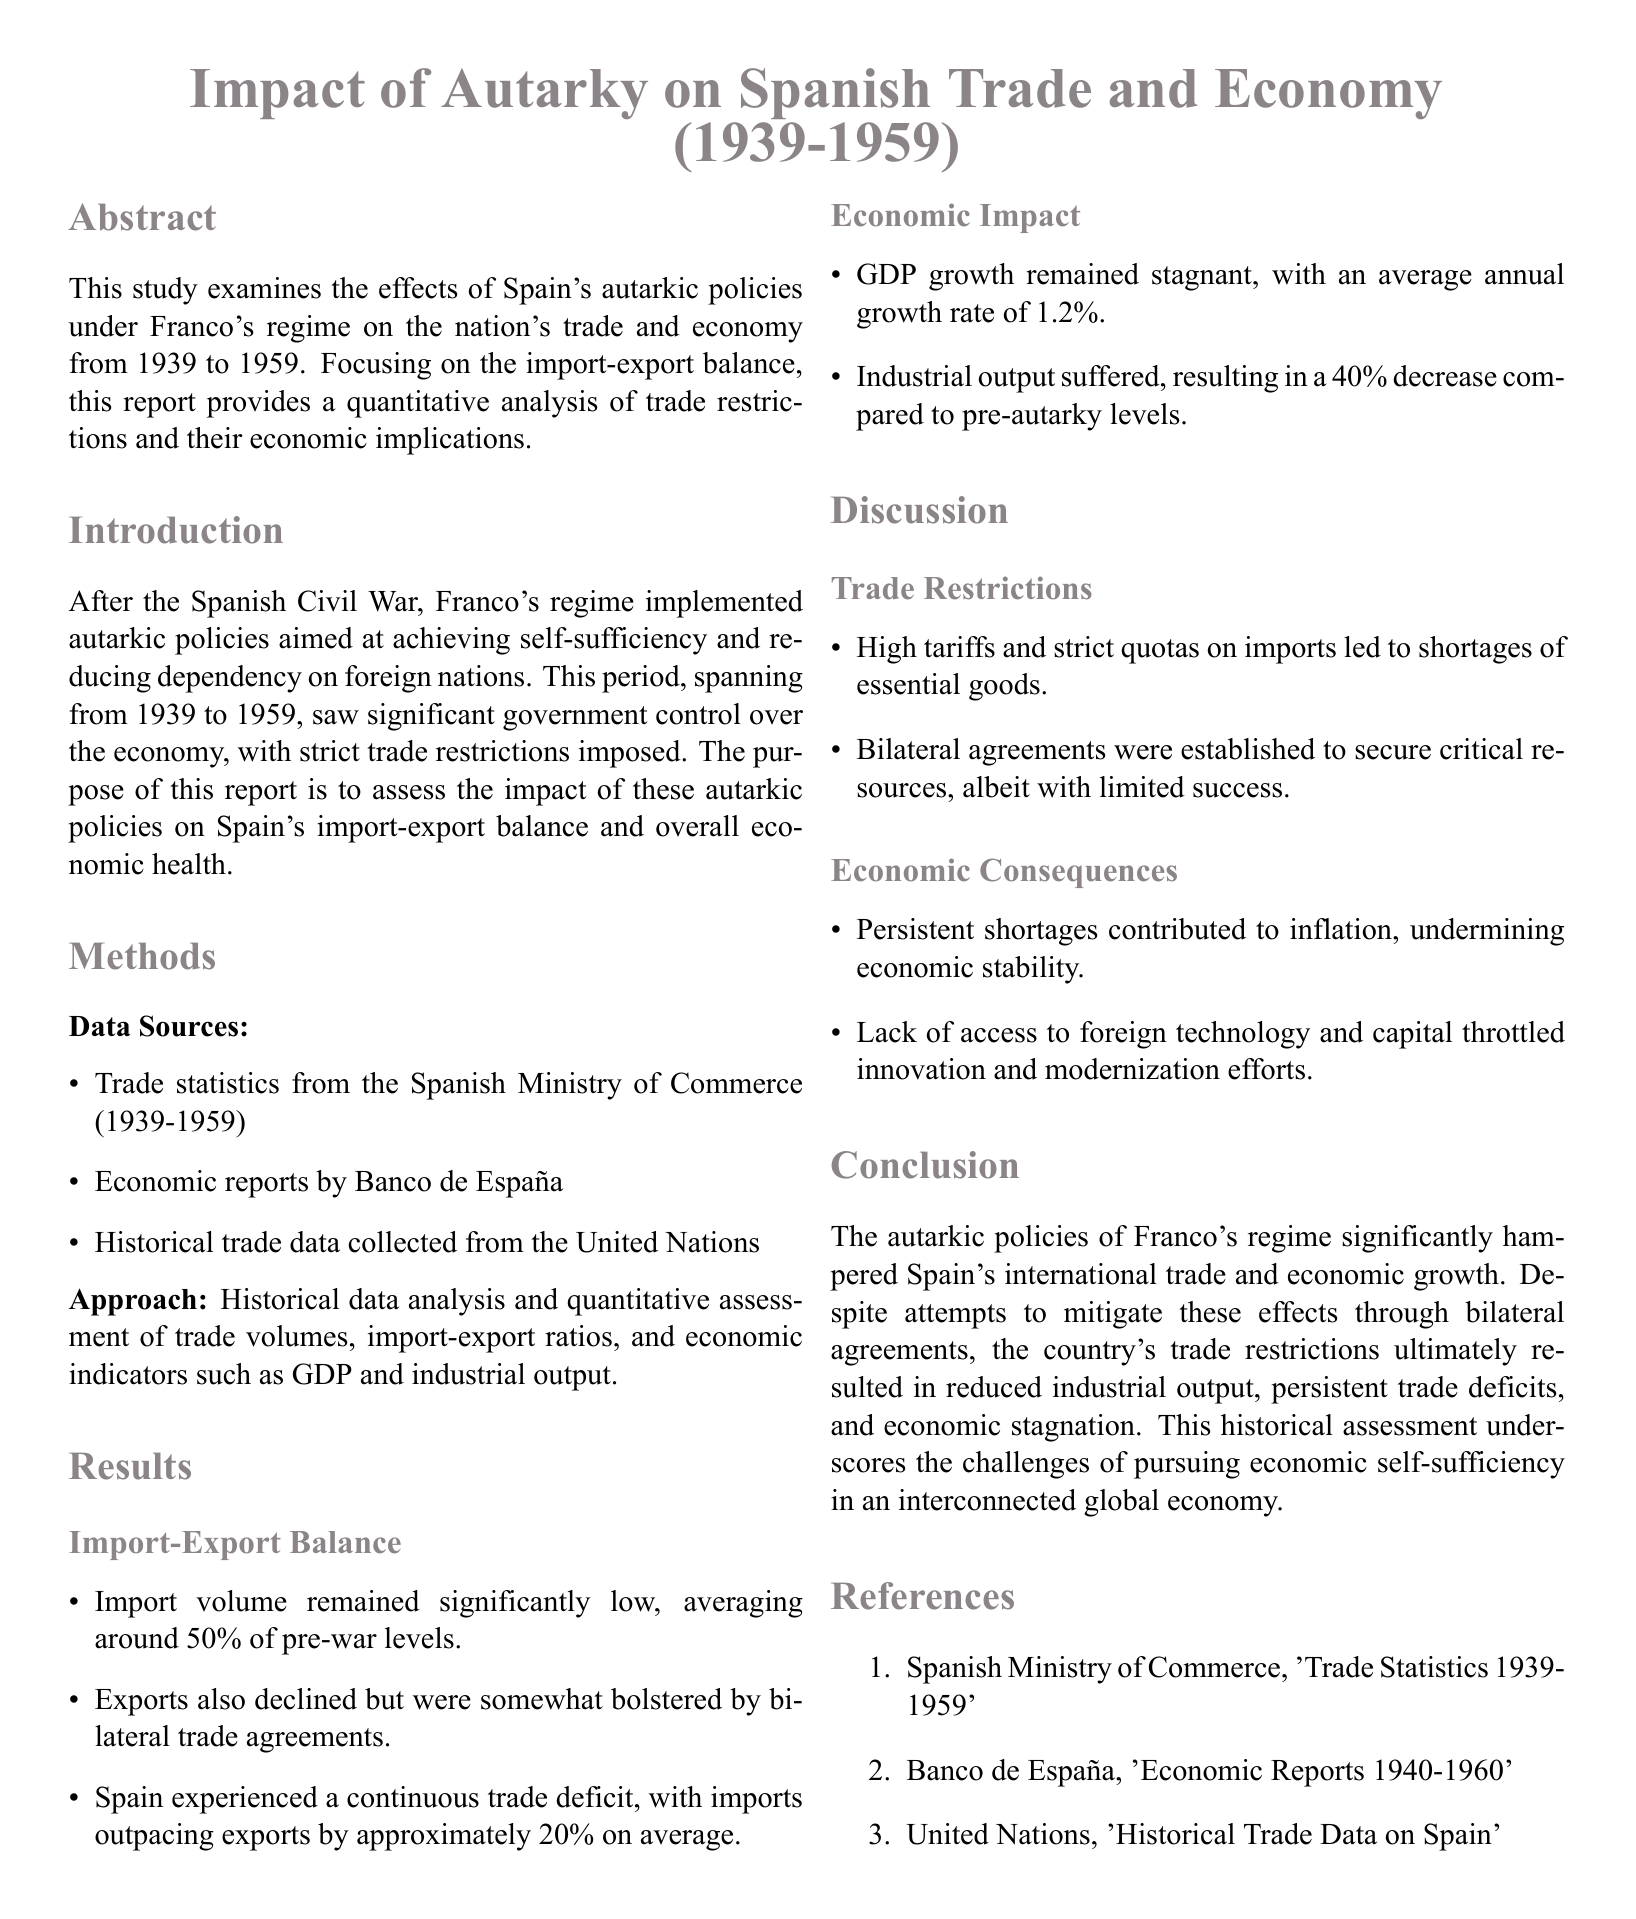what time period does the report cover? The report covers the economic policies of Franco's regime from 1939 to 1959.
Answer: 1939-1959 what was the average annual GDP growth rate? The average annual GDP growth rate during this period was stated in the results section.
Answer: 1.2% how much did industrial output decrease compared to pre-autarky levels? This information can be found in the results regarding economic impact.
Answer: 40% what trade relationship was highlighted as a method to mitigate trade deficits? The results of the discussion section mention agreements established between countries.
Answer: Bilateral agreements what was the impact of high tariffs according to the discussion? The discussion elaborates on the consequences of these trade restrictions.
Answer: Shortages of essential goods which organization provided historical trade data? The sources for trade data are listed in the methods section.
Answer: United Nations what was the import outpacing exports by on average? This quantitative detail can be found within the results section on import-export balance.
Answer: 20% what was the main conclusion of the report? The conclusion summarizes the overall findings on autarkic policies and their effects.
Answer: Economic stagnation 